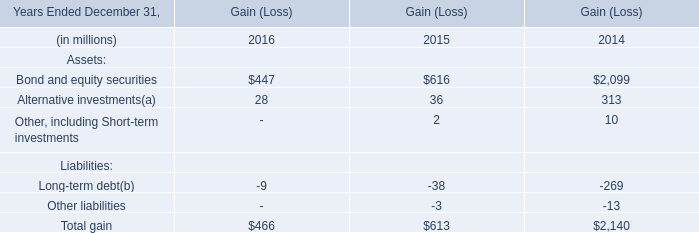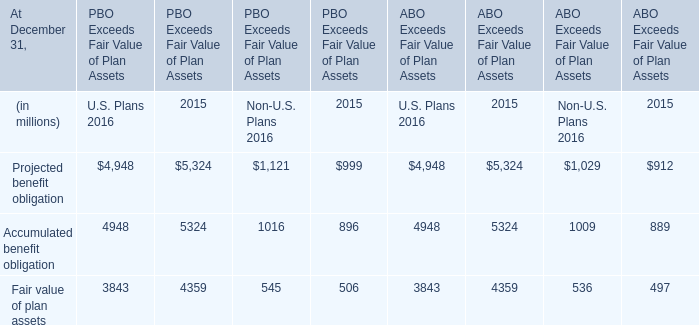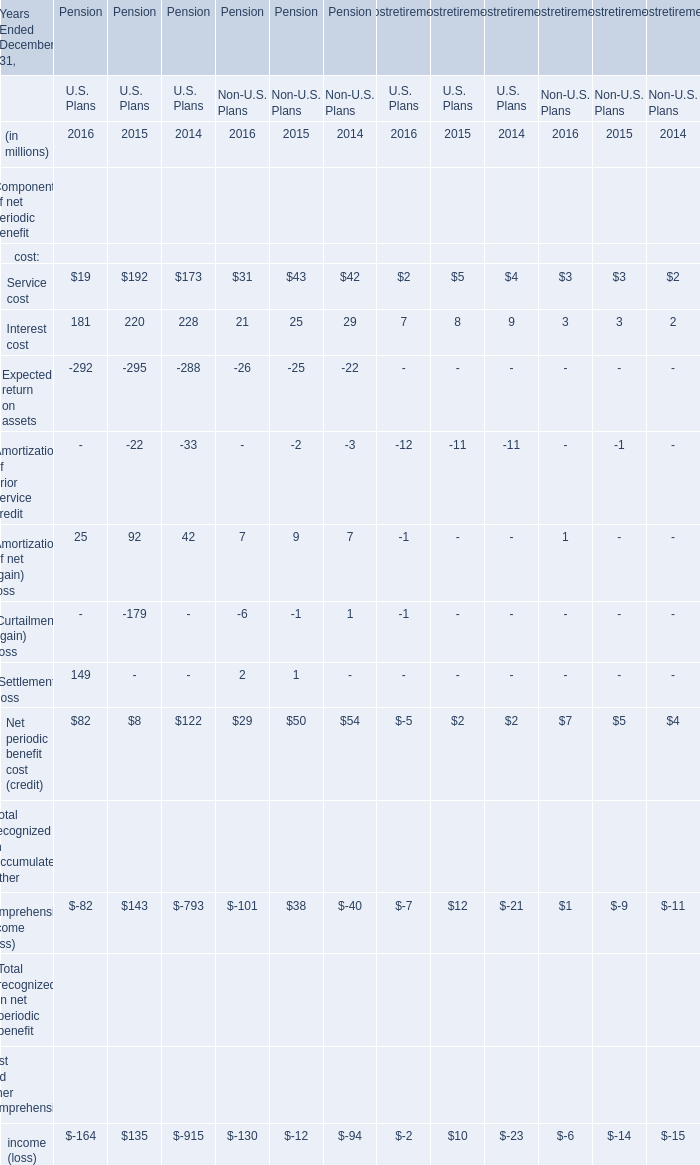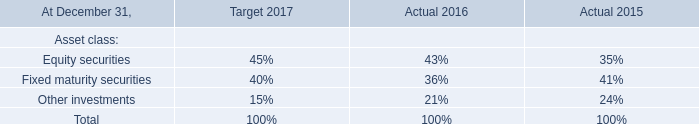what is the average price per share for the repurchased shares during 2006? 
Computations: (892 / 19)
Answer: 46.94737. 